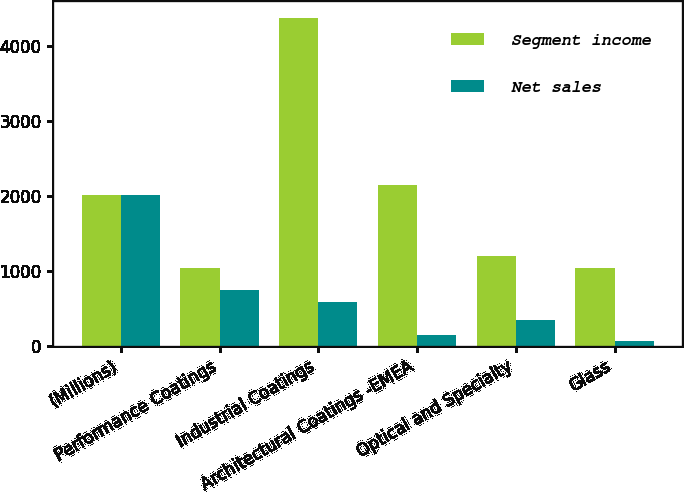<chart> <loc_0><loc_0><loc_500><loc_500><stacked_bar_chart><ecel><fcel>(Millions)<fcel>Performance Coatings<fcel>Industrial Coatings<fcel>Architectural Coatings -EMEA<fcel>Optical and Specialty<fcel>Glass<nl><fcel>Segment income<fcel>2012<fcel>1032<fcel>4379<fcel>2147<fcel>1202<fcel>1032<nl><fcel>Net sales<fcel>2012<fcel>744<fcel>590<fcel>145<fcel>348<fcel>63<nl></chart> 